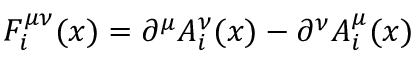Convert formula to latex. <formula><loc_0><loc_0><loc_500><loc_500>F _ { i } ^ { \mu \nu } ( x ) = \partial ^ { \mu } A _ { i } ^ { \nu } ( x ) - \partial ^ { \nu } A _ { i } ^ { \mu } ( x )</formula> 